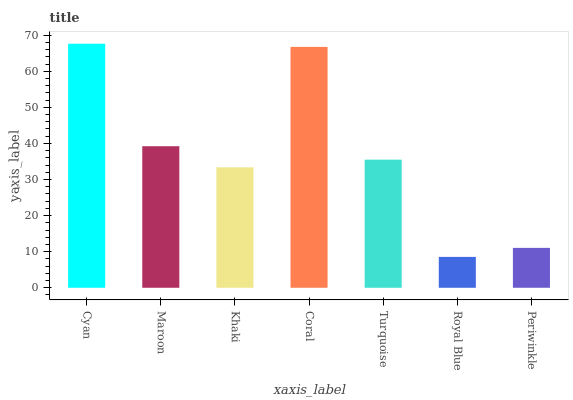Is Royal Blue the minimum?
Answer yes or no. Yes. Is Cyan the maximum?
Answer yes or no. Yes. Is Maroon the minimum?
Answer yes or no. No. Is Maroon the maximum?
Answer yes or no. No. Is Cyan greater than Maroon?
Answer yes or no. Yes. Is Maroon less than Cyan?
Answer yes or no. Yes. Is Maroon greater than Cyan?
Answer yes or no. No. Is Cyan less than Maroon?
Answer yes or no. No. Is Turquoise the high median?
Answer yes or no. Yes. Is Turquoise the low median?
Answer yes or no. Yes. Is Cyan the high median?
Answer yes or no. No. Is Maroon the low median?
Answer yes or no. No. 